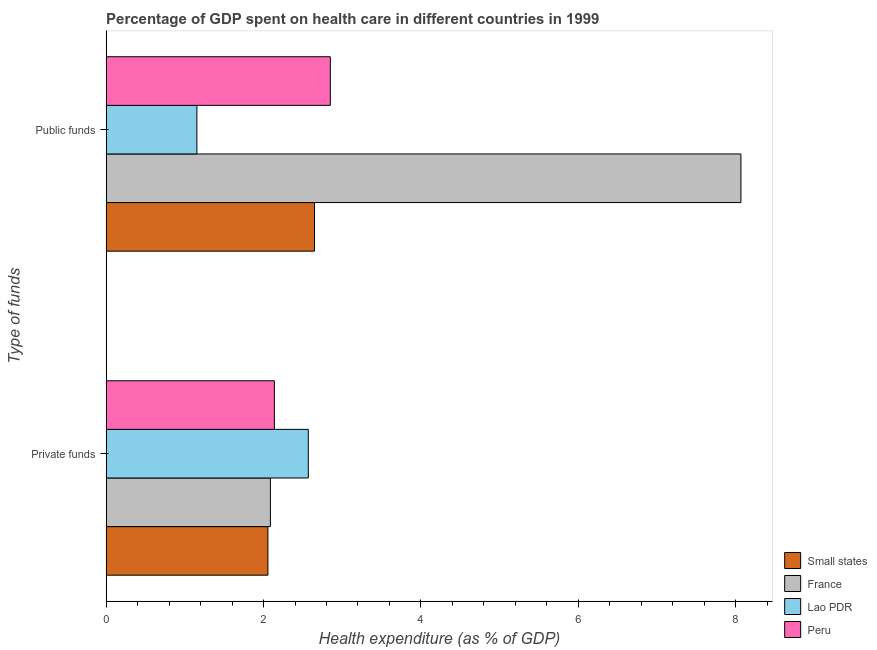How many groups of bars are there?
Ensure brevity in your answer.  2. Are the number of bars on each tick of the Y-axis equal?
Your answer should be compact. Yes. How many bars are there on the 2nd tick from the top?
Your answer should be compact. 4. How many bars are there on the 2nd tick from the bottom?
Your answer should be very brief. 4. What is the label of the 2nd group of bars from the top?
Your answer should be compact. Private funds. What is the amount of private funds spent in healthcare in France?
Ensure brevity in your answer.  2.09. Across all countries, what is the maximum amount of public funds spent in healthcare?
Keep it short and to the point. 8.07. Across all countries, what is the minimum amount of public funds spent in healthcare?
Ensure brevity in your answer.  1.15. In which country was the amount of private funds spent in healthcare maximum?
Make the answer very short. Lao PDR. In which country was the amount of private funds spent in healthcare minimum?
Your response must be concise. Small states. What is the total amount of public funds spent in healthcare in the graph?
Your answer should be compact. 14.72. What is the difference between the amount of private funds spent in healthcare in Lao PDR and that in France?
Your answer should be very brief. 0.48. What is the difference between the amount of private funds spent in healthcare in Lao PDR and the amount of public funds spent in healthcare in Small states?
Ensure brevity in your answer.  -0.08. What is the average amount of public funds spent in healthcare per country?
Provide a short and direct response. 3.68. What is the difference between the amount of public funds spent in healthcare and amount of private funds spent in healthcare in France?
Your answer should be compact. 5.98. What is the ratio of the amount of public funds spent in healthcare in France to that in Small states?
Make the answer very short. 3.05. Is the amount of private funds spent in healthcare in Peru less than that in Small states?
Ensure brevity in your answer.  No. What does the 3rd bar from the top in Private funds represents?
Ensure brevity in your answer.  France. How many bars are there?
Make the answer very short. 8. How many countries are there in the graph?
Offer a terse response. 4. What is the difference between two consecutive major ticks on the X-axis?
Ensure brevity in your answer.  2. How are the legend labels stacked?
Provide a short and direct response. Vertical. What is the title of the graph?
Your response must be concise. Percentage of GDP spent on health care in different countries in 1999. What is the label or title of the X-axis?
Offer a terse response. Health expenditure (as % of GDP). What is the label or title of the Y-axis?
Give a very brief answer. Type of funds. What is the Health expenditure (as % of GDP) in Small states in Private funds?
Your answer should be very brief. 2.06. What is the Health expenditure (as % of GDP) in France in Private funds?
Your answer should be compact. 2.09. What is the Health expenditure (as % of GDP) of Lao PDR in Private funds?
Your answer should be very brief. 2.57. What is the Health expenditure (as % of GDP) in Peru in Private funds?
Offer a very short reply. 2.14. What is the Health expenditure (as % of GDP) of Small states in Public funds?
Keep it short and to the point. 2.65. What is the Health expenditure (as % of GDP) of France in Public funds?
Ensure brevity in your answer.  8.07. What is the Health expenditure (as % of GDP) in Lao PDR in Public funds?
Make the answer very short. 1.15. What is the Health expenditure (as % of GDP) in Peru in Public funds?
Your answer should be compact. 2.85. Across all Type of funds, what is the maximum Health expenditure (as % of GDP) in Small states?
Offer a very short reply. 2.65. Across all Type of funds, what is the maximum Health expenditure (as % of GDP) of France?
Your response must be concise. 8.07. Across all Type of funds, what is the maximum Health expenditure (as % of GDP) of Lao PDR?
Offer a terse response. 2.57. Across all Type of funds, what is the maximum Health expenditure (as % of GDP) in Peru?
Make the answer very short. 2.85. Across all Type of funds, what is the minimum Health expenditure (as % of GDP) of Small states?
Make the answer very short. 2.06. Across all Type of funds, what is the minimum Health expenditure (as % of GDP) of France?
Provide a succinct answer. 2.09. Across all Type of funds, what is the minimum Health expenditure (as % of GDP) in Lao PDR?
Ensure brevity in your answer.  1.15. Across all Type of funds, what is the minimum Health expenditure (as % of GDP) of Peru?
Keep it short and to the point. 2.14. What is the total Health expenditure (as % of GDP) in Small states in the graph?
Offer a terse response. 4.7. What is the total Health expenditure (as % of GDP) of France in the graph?
Provide a short and direct response. 10.15. What is the total Health expenditure (as % of GDP) in Lao PDR in the graph?
Make the answer very short. 3.72. What is the total Health expenditure (as % of GDP) of Peru in the graph?
Make the answer very short. 4.99. What is the difference between the Health expenditure (as % of GDP) in Small states in Private funds and that in Public funds?
Your answer should be very brief. -0.59. What is the difference between the Health expenditure (as % of GDP) of France in Private funds and that in Public funds?
Your answer should be very brief. -5.98. What is the difference between the Health expenditure (as % of GDP) of Lao PDR in Private funds and that in Public funds?
Make the answer very short. 1.42. What is the difference between the Health expenditure (as % of GDP) in Peru in Private funds and that in Public funds?
Ensure brevity in your answer.  -0.71. What is the difference between the Health expenditure (as % of GDP) in Small states in Private funds and the Health expenditure (as % of GDP) in France in Public funds?
Ensure brevity in your answer.  -6.01. What is the difference between the Health expenditure (as % of GDP) of Small states in Private funds and the Health expenditure (as % of GDP) of Lao PDR in Public funds?
Give a very brief answer. 0.9. What is the difference between the Health expenditure (as % of GDP) of Small states in Private funds and the Health expenditure (as % of GDP) of Peru in Public funds?
Offer a very short reply. -0.79. What is the difference between the Health expenditure (as % of GDP) in France in Private funds and the Health expenditure (as % of GDP) in Lao PDR in Public funds?
Offer a very short reply. 0.93. What is the difference between the Health expenditure (as % of GDP) in France in Private funds and the Health expenditure (as % of GDP) in Peru in Public funds?
Offer a terse response. -0.76. What is the difference between the Health expenditure (as % of GDP) in Lao PDR in Private funds and the Health expenditure (as % of GDP) in Peru in Public funds?
Your response must be concise. -0.28. What is the average Health expenditure (as % of GDP) in Small states per Type of funds?
Your response must be concise. 2.35. What is the average Health expenditure (as % of GDP) in France per Type of funds?
Offer a terse response. 5.08. What is the average Health expenditure (as % of GDP) of Lao PDR per Type of funds?
Provide a short and direct response. 1.86. What is the average Health expenditure (as % of GDP) in Peru per Type of funds?
Offer a terse response. 2.49. What is the difference between the Health expenditure (as % of GDP) of Small states and Health expenditure (as % of GDP) of France in Private funds?
Your response must be concise. -0.03. What is the difference between the Health expenditure (as % of GDP) of Small states and Health expenditure (as % of GDP) of Lao PDR in Private funds?
Provide a short and direct response. -0.51. What is the difference between the Health expenditure (as % of GDP) of Small states and Health expenditure (as % of GDP) of Peru in Private funds?
Ensure brevity in your answer.  -0.08. What is the difference between the Health expenditure (as % of GDP) of France and Health expenditure (as % of GDP) of Lao PDR in Private funds?
Keep it short and to the point. -0.48. What is the difference between the Health expenditure (as % of GDP) of France and Health expenditure (as % of GDP) of Peru in Private funds?
Provide a succinct answer. -0.05. What is the difference between the Health expenditure (as % of GDP) of Lao PDR and Health expenditure (as % of GDP) of Peru in Private funds?
Give a very brief answer. 0.43. What is the difference between the Health expenditure (as % of GDP) in Small states and Health expenditure (as % of GDP) in France in Public funds?
Your answer should be very brief. -5.42. What is the difference between the Health expenditure (as % of GDP) in Small states and Health expenditure (as % of GDP) in Lao PDR in Public funds?
Make the answer very short. 1.49. What is the difference between the Health expenditure (as % of GDP) of Small states and Health expenditure (as % of GDP) of Peru in Public funds?
Give a very brief answer. -0.2. What is the difference between the Health expenditure (as % of GDP) of France and Health expenditure (as % of GDP) of Lao PDR in Public funds?
Your answer should be compact. 6.91. What is the difference between the Health expenditure (as % of GDP) of France and Health expenditure (as % of GDP) of Peru in Public funds?
Ensure brevity in your answer.  5.22. What is the difference between the Health expenditure (as % of GDP) of Lao PDR and Health expenditure (as % of GDP) of Peru in Public funds?
Give a very brief answer. -1.7. What is the ratio of the Health expenditure (as % of GDP) in Small states in Private funds to that in Public funds?
Offer a very short reply. 0.78. What is the ratio of the Health expenditure (as % of GDP) of France in Private funds to that in Public funds?
Make the answer very short. 0.26. What is the ratio of the Health expenditure (as % of GDP) in Lao PDR in Private funds to that in Public funds?
Offer a terse response. 2.23. What is the ratio of the Health expenditure (as % of GDP) of Peru in Private funds to that in Public funds?
Your response must be concise. 0.75. What is the difference between the highest and the second highest Health expenditure (as % of GDP) in Small states?
Offer a terse response. 0.59. What is the difference between the highest and the second highest Health expenditure (as % of GDP) of France?
Ensure brevity in your answer.  5.98. What is the difference between the highest and the second highest Health expenditure (as % of GDP) of Lao PDR?
Your answer should be very brief. 1.42. What is the difference between the highest and the second highest Health expenditure (as % of GDP) in Peru?
Your answer should be very brief. 0.71. What is the difference between the highest and the lowest Health expenditure (as % of GDP) in Small states?
Give a very brief answer. 0.59. What is the difference between the highest and the lowest Health expenditure (as % of GDP) in France?
Your answer should be compact. 5.98. What is the difference between the highest and the lowest Health expenditure (as % of GDP) in Lao PDR?
Offer a very short reply. 1.42. What is the difference between the highest and the lowest Health expenditure (as % of GDP) in Peru?
Ensure brevity in your answer.  0.71. 